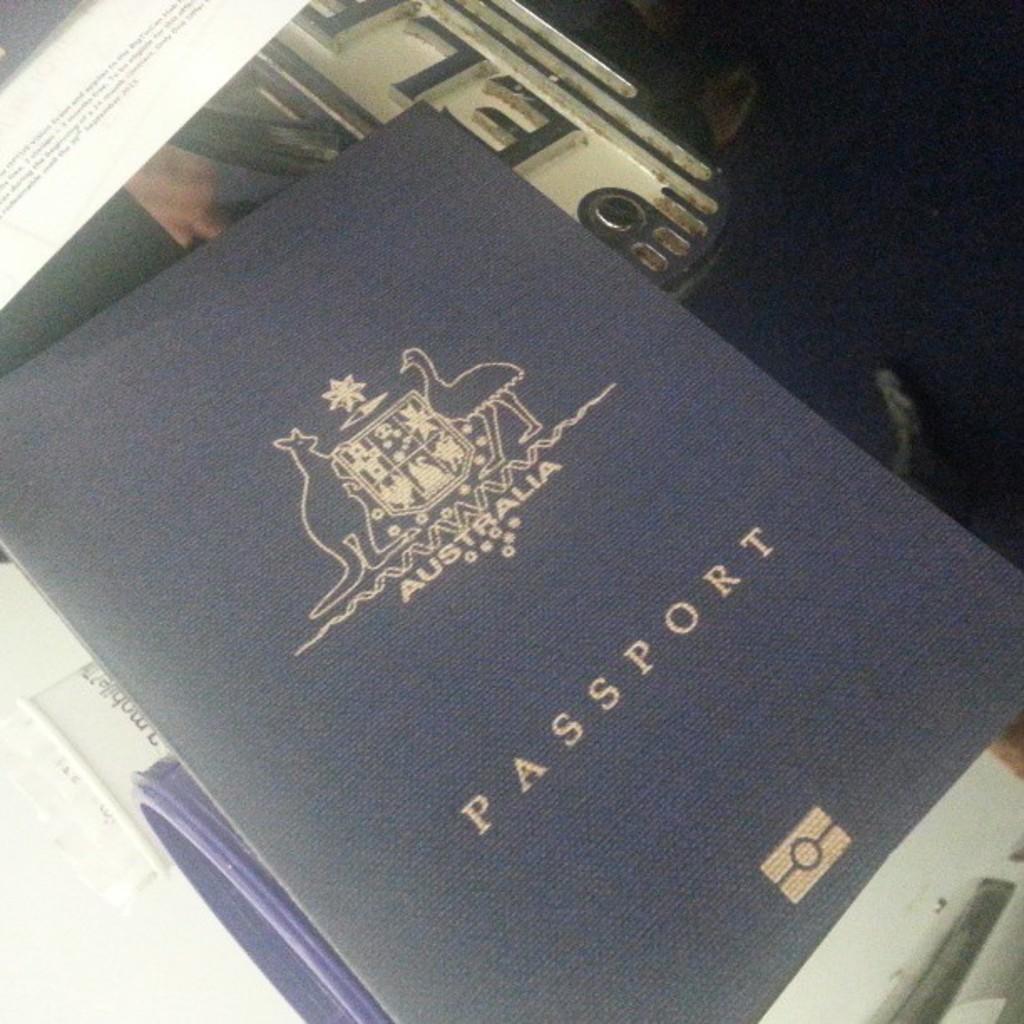Australia is issued the passport?
Ensure brevity in your answer.  Yes. 